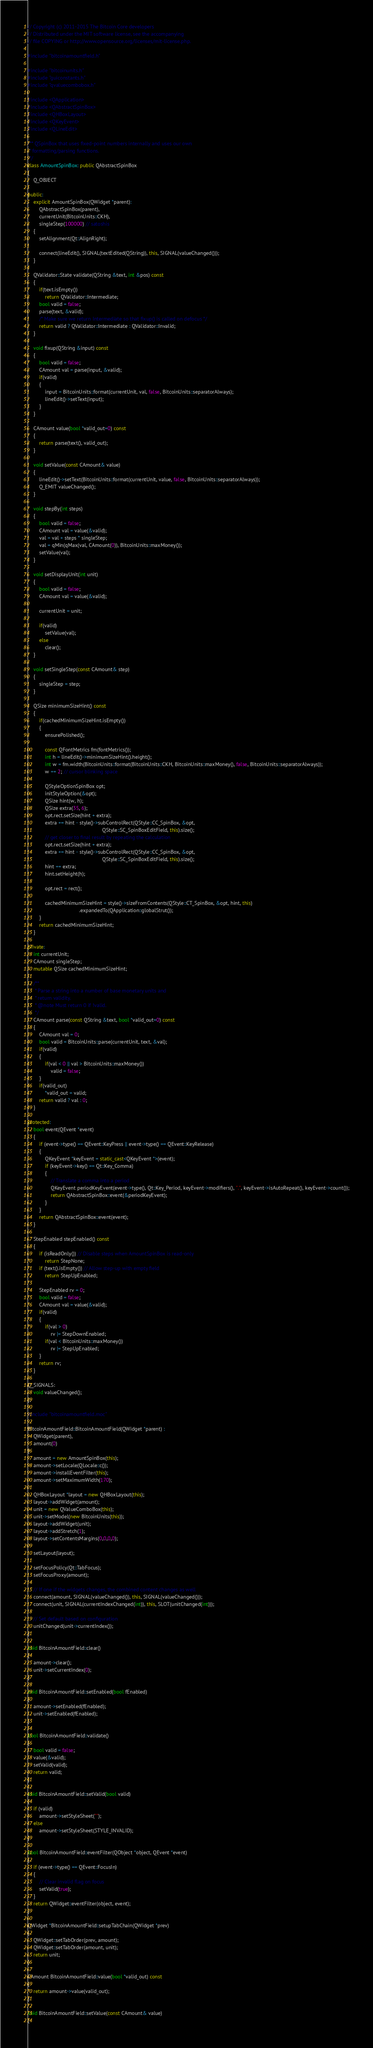<code> <loc_0><loc_0><loc_500><loc_500><_C++_>// Copyright (c) 2011-2015 The Bitcoin Core developers
// Distributed under the MIT software license, see the accompanying
// file COPYING or http://www.opensource.org/licenses/mit-license.php.

#include "bitcoinamountfield.h"

#include "bitcoinunits.h"
#include "guiconstants.h"
#include "qvaluecombobox.h"

#include <QApplication>
#include <QAbstractSpinBox>
#include <QHBoxLayout>
#include <QKeyEvent>
#include <QLineEdit>

/** QSpinBox that uses fixed-point numbers internally and uses our own
 * formatting/parsing functions.
 */
class AmountSpinBox: public QAbstractSpinBox
{
    Q_OBJECT

public:
    explicit AmountSpinBox(QWidget *parent):
        QAbstractSpinBox(parent),
        currentUnit(BitcoinUnits::CKH),
        singleStep(100000) // satoshis
    {
        setAlignment(Qt::AlignRight);

        connect(lineEdit(), SIGNAL(textEdited(QString)), this, SIGNAL(valueChanged()));
    }

    QValidator::State validate(QString &text, int &pos) const
    {
        if(text.isEmpty())
            return QValidator::Intermediate;
        bool valid = false;
        parse(text, &valid);
        /* Make sure we return Intermediate so that fixup() is called on defocus */
        return valid ? QValidator::Intermediate : QValidator::Invalid;
    }

    void fixup(QString &input) const
    {
        bool valid = false;
        CAmount val = parse(input, &valid);
        if(valid)
        {
            input = BitcoinUnits::format(currentUnit, val, false, BitcoinUnits::separatorAlways);
            lineEdit()->setText(input);
        }
    }

    CAmount value(bool *valid_out=0) const
    {
        return parse(text(), valid_out);
    }

    void setValue(const CAmount& value)
    {
        lineEdit()->setText(BitcoinUnits::format(currentUnit, value, false, BitcoinUnits::separatorAlways));
        Q_EMIT valueChanged();
    }

    void stepBy(int steps)
    {
        bool valid = false;
        CAmount val = value(&valid);
        val = val + steps * singleStep;
        val = qMin(qMax(val, CAmount(0)), BitcoinUnits::maxMoney());
        setValue(val);
    }

    void setDisplayUnit(int unit)
    {
        bool valid = false;
        CAmount val = value(&valid);

        currentUnit = unit;

        if(valid)
            setValue(val);
        else
            clear();
    }

    void setSingleStep(const CAmount& step)
    {
        singleStep = step;
    }

    QSize minimumSizeHint() const
    {
        if(cachedMinimumSizeHint.isEmpty())
        {
            ensurePolished();

            const QFontMetrics fm(fontMetrics());
            int h = lineEdit()->minimumSizeHint().height();
            int w = fm.width(BitcoinUnits::format(BitcoinUnits::CKH, BitcoinUnits::maxMoney(), false, BitcoinUnits::separatorAlways));
            w += 2; // cursor blinking space

            QStyleOptionSpinBox opt;
            initStyleOption(&opt);
            QSize hint(w, h);
            QSize extra(35, 6);
            opt.rect.setSize(hint + extra);
            extra += hint - style()->subControlRect(QStyle::CC_SpinBox, &opt,
                                                    QStyle::SC_SpinBoxEditField, this).size();
            // get closer to final result by repeating the calculation
            opt.rect.setSize(hint + extra);
            extra += hint - style()->subControlRect(QStyle::CC_SpinBox, &opt,
                                                    QStyle::SC_SpinBoxEditField, this).size();
            hint += extra;
            hint.setHeight(h);

            opt.rect = rect();

            cachedMinimumSizeHint = style()->sizeFromContents(QStyle::CT_SpinBox, &opt, hint, this)
                                    .expandedTo(QApplication::globalStrut());
        }
        return cachedMinimumSizeHint;
    }

private:
    int currentUnit;
    CAmount singleStep;
    mutable QSize cachedMinimumSizeHint;

    /**
     * Parse a string into a number of base monetary units and
     * return validity.
     * @note Must return 0 if !valid.
     */
    CAmount parse(const QString &text, bool *valid_out=0) const
    {
        CAmount val = 0;
        bool valid = BitcoinUnits::parse(currentUnit, text, &val);
        if(valid)
        {
            if(val < 0 || val > BitcoinUnits::maxMoney())
                valid = false;
        }
        if(valid_out)
            *valid_out = valid;
        return valid ? val : 0;
    }

protected:
    bool event(QEvent *event)
    {
        if (event->type() == QEvent::KeyPress || event->type() == QEvent::KeyRelease)
        {
            QKeyEvent *keyEvent = static_cast<QKeyEvent *>(event);
            if (keyEvent->key() == Qt::Key_Comma)
            {
                // Translate a comma into a period
                QKeyEvent periodKeyEvent(event->type(), Qt::Key_Period, keyEvent->modifiers(), ".", keyEvent->isAutoRepeat(), keyEvent->count());
                return QAbstractSpinBox::event(&periodKeyEvent);
            }
        }
        return QAbstractSpinBox::event(event);
    }

    StepEnabled stepEnabled() const
    {
        if (isReadOnly()) // Disable steps when AmountSpinBox is read-only
            return StepNone;
        if (text().isEmpty()) // Allow step-up with empty field
            return StepUpEnabled;

        StepEnabled rv = 0;
        bool valid = false;
        CAmount val = value(&valid);
        if(valid)
        {
            if(val > 0)
                rv |= StepDownEnabled;
            if(val < BitcoinUnits::maxMoney())
                rv |= StepUpEnabled;
        }
        return rv;
    }

Q_SIGNALS:
    void valueChanged();
};

#include "bitcoinamountfield.moc"

BitcoinAmountField::BitcoinAmountField(QWidget *parent) :
    QWidget(parent),
    amount(0)
{
    amount = new AmountSpinBox(this);
    amount->setLocale(QLocale::c());
    amount->installEventFilter(this);
    amount->setMaximumWidth(170);

    QHBoxLayout *layout = new QHBoxLayout(this);
    layout->addWidget(amount);
    unit = new QValueComboBox(this);
    unit->setModel(new BitcoinUnits(this));
    layout->addWidget(unit);
    layout->addStretch(1);
    layout->setContentsMargins(0,0,0,0);

    setLayout(layout);

    setFocusPolicy(Qt::TabFocus);
    setFocusProxy(amount);

    // If one if the widgets changes, the combined content changes as well
    connect(amount, SIGNAL(valueChanged()), this, SIGNAL(valueChanged()));
    connect(unit, SIGNAL(currentIndexChanged(int)), this, SLOT(unitChanged(int)));

    // Set default based on configuration
    unitChanged(unit->currentIndex());
}

void BitcoinAmountField::clear()
{
    amount->clear();
    unit->setCurrentIndex(0);
}

void BitcoinAmountField::setEnabled(bool fEnabled)
{
    amount->setEnabled(fEnabled);
    unit->setEnabled(fEnabled);
}

bool BitcoinAmountField::validate()
{
    bool valid = false;
    value(&valid);
    setValid(valid);
    return valid;
}

void BitcoinAmountField::setValid(bool valid)
{
    if (valid)
        amount->setStyleSheet("");
    else
        amount->setStyleSheet(STYLE_INVALID);
}

bool BitcoinAmountField::eventFilter(QObject *object, QEvent *event)
{
    if (event->type() == QEvent::FocusIn)
    {
        // Clear invalid flag on focus
        setValid(true);
    }
    return QWidget::eventFilter(object, event);
}

QWidget *BitcoinAmountField::setupTabChain(QWidget *prev)
{
    QWidget::setTabOrder(prev, amount);
    QWidget::setTabOrder(amount, unit);
    return unit;
}

CAmount BitcoinAmountField::value(bool *valid_out) const
{
    return amount->value(valid_out);
}

void BitcoinAmountField::setValue(const CAmount& value)
{</code> 